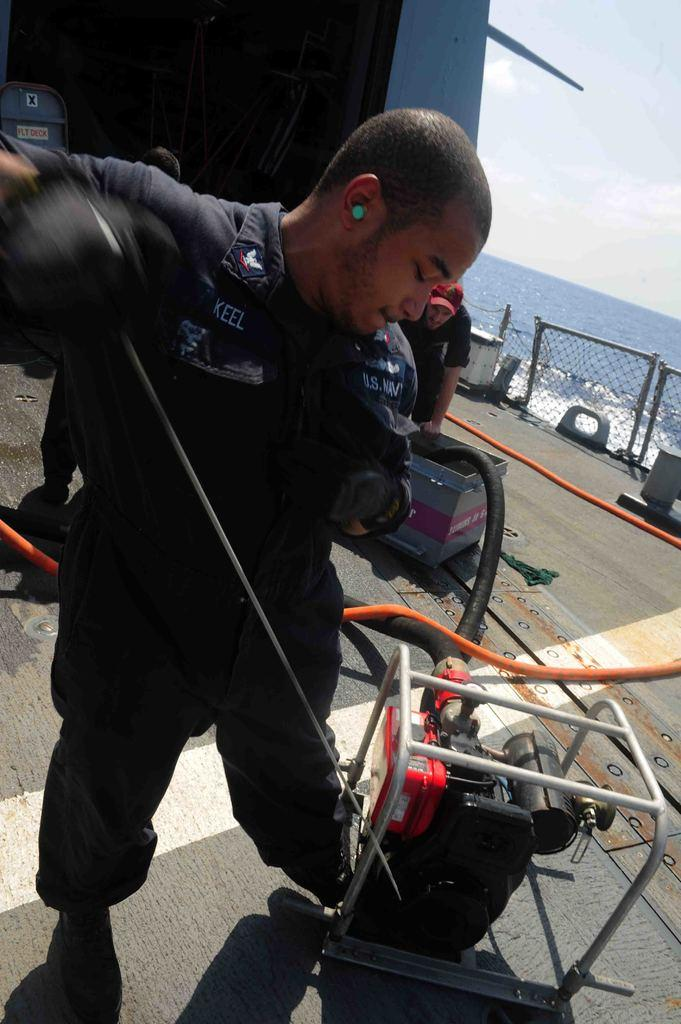What can be seen in the image involving people? There are people standing in the image. What type of equipment is present in the image? There is a machine in the image. What is the pipe used for in the image? The pipe is present in the image, but its purpose is not specified. Can you describe any other objects in the image? There are other objects present in the image, but their specific details are not mentioned. What can be seen in the background of the image? There is water and fencing visible in the background of the image. What type of clover can be seen growing near the machine in the image? There is no clover present in the image. How does the water taste in the image? The taste of the water cannot be determined from the image. 